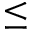Convert formula to latex. <formula><loc_0><loc_0><loc_500><loc_500>\leq</formula> 